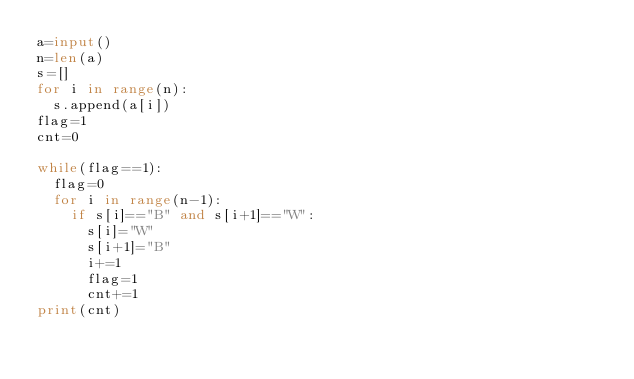Convert code to text. <code><loc_0><loc_0><loc_500><loc_500><_Python_>a=input()
n=len(a)
s=[]
for i in range(n):
  s.append(a[i])
flag=1
cnt=0

while(flag==1):
  flag=0
  for i in range(n-1):
    if s[i]=="B" and s[i+1]=="W":
      s[i]="W"
      s[i+1]="B"
      i+=1
      flag=1
      cnt+=1
print(cnt)</code> 